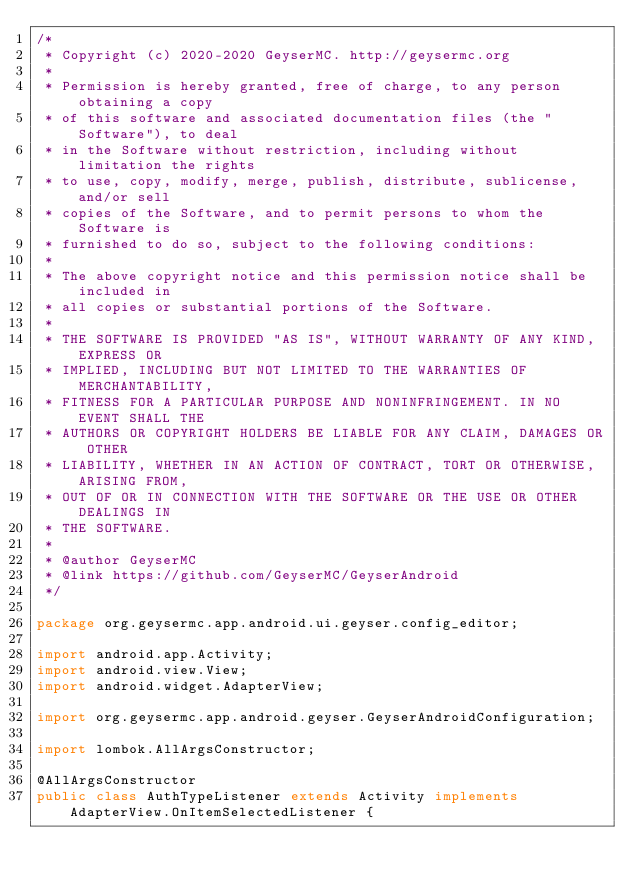Convert code to text. <code><loc_0><loc_0><loc_500><loc_500><_Java_>/*
 * Copyright (c) 2020-2020 GeyserMC. http://geysermc.org
 *
 * Permission is hereby granted, free of charge, to any person obtaining a copy
 * of this software and associated documentation files (the "Software"), to deal
 * in the Software without restriction, including without limitation the rights
 * to use, copy, modify, merge, publish, distribute, sublicense, and/or sell
 * copies of the Software, and to permit persons to whom the Software is
 * furnished to do so, subject to the following conditions:
 *
 * The above copyright notice and this permission notice shall be included in
 * all copies or substantial portions of the Software.
 *
 * THE SOFTWARE IS PROVIDED "AS IS", WITHOUT WARRANTY OF ANY KIND, EXPRESS OR
 * IMPLIED, INCLUDING BUT NOT LIMITED TO THE WARRANTIES OF MERCHANTABILITY,
 * FITNESS FOR A PARTICULAR PURPOSE AND NONINFRINGEMENT. IN NO EVENT SHALL THE
 * AUTHORS OR COPYRIGHT HOLDERS BE LIABLE FOR ANY CLAIM, DAMAGES OR OTHER
 * LIABILITY, WHETHER IN AN ACTION OF CONTRACT, TORT OR OTHERWISE, ARISING FROM,
 * OUT OF OR IN CONNECTION WITH THE SOFTWARE OR THE USE OR OTHER DEALINGS IN
 * THE SOFTWARE.
 *
 * @author GeyserMC
 * @link https://github.com/GeyserMC/GeyserAndroid
 */

package org.geysermc.app.android.ui.geyser.config_editor;

import android.app.Activity;
import android.view.View;
import android.widget.AdapterView;

import org.geysermc.app.android.geyser.GeyserAndroidConfiguration;

import lombok.AllArgsConstructor;

@AllArgsConstructor
public class AuthTypeListener extends Activity implements AdapterView.OnItemSelectedListener {
</code> 